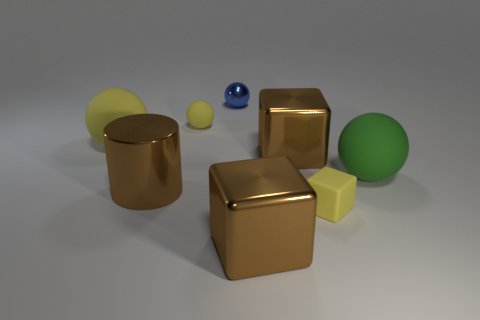What number of big objects are brown blocks or red rubber objects?
Your answer should be compact. 2. What is the shape of the yellow thing that is the same size as the green ball?
Provide a succinct answer. Sphere. The yellow ball that is on the left side of the small yellow thing left of the tiny yellow matte cube is made of what material?
Provide a short and direct response. Rubber. Do the matte block and the blue metallic ball have the same size?
Your answer should be compact. Yes. How many things are things to the left of the tiny yellow block or small yellow rubber cylinders?
Give a very brief answer. 6. The matte object that is behind the large ball that is on the left side of the blue thing is what shape?
Provide a succinct answer. Sphere. Do the green rubber thing and the thing that is behind the tiny rubber ball have the same size?
Provide a succinct answer. No. What material is the small object that is in front of the brown cylinder?
Provide a succinct answer. Rubber. What number of brown metal things are in front of the large green rubber object and right of the tiny yellow rubber ball?
Make the answer very short. 1. There is a blue ball that is the same size as the yellow rubber block; what is it made of?
Give a very brief answer. Metal. 